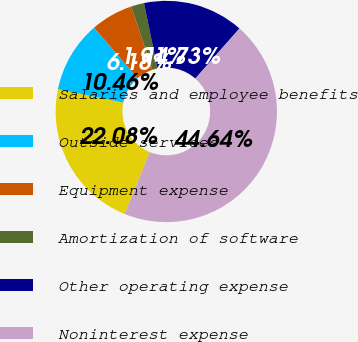Convert chart to OTSL. <chart><loc_0><loc_0><loc_500><loc_500><pie_chart><fcel>Salaries and employee benefits<fcel>Outside services<fcel>Equipment expense<fcel>Amortization of software<fcel>Other operating expense<fcel>Noninterest expense<nl><fcel>22.08%<fcel>10.46%<fcel>6.18%<fcel>1.91%<fcel>14.73%<fcel>44.64%<nl></chart> 